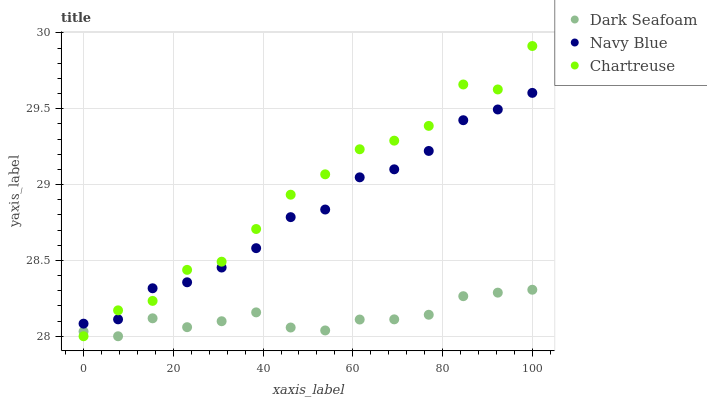Does Dark Seafoam have the minimum area under the curve?
Answer yes or no. Yes. Does Chartreuse have the maximum area under the curve?
Answer yes or no. Yes. Does Chartreuse have the minimum area under the curve?
Answer yes or no. No. Does Dark Seafoam have the maximum area under the curve?
Answer yes or no. No. Is Dark Seafoam the smoothest?
Answer yes or no. Yes. Is Chartreuse the roughest?
Answer yes or no. Yes. Is Chartreuse the smoothest?
Answer yes or no. No. Is Dark Seafoam the roughest?
Answer yes or no. No. Does Dark Seafoam have the lowest value?
Answer yes or no. Yes. Does Chartreuse have the highest value?
Answer yes or no. Yes. Does Dark Seafoam have the highest value?
Answer yes or no. No. Is Dark Seafoam less than Navy Blue?
Answer yes or no. Yes. Is Navy Blue greater than Dark Seafoam?
Answer yes or no. Yes. Does Navy Blue intersect Chartreuse?
Answer yes or no. Yes. Is Navy Blue less than Chartreuse?
Answer yes or no. No. Is Navy Blue greater than Chartreuse?
Answer yes or no. No. Does Dark Seafoam intersect Navy Blue?
Answer yes or no. No. 